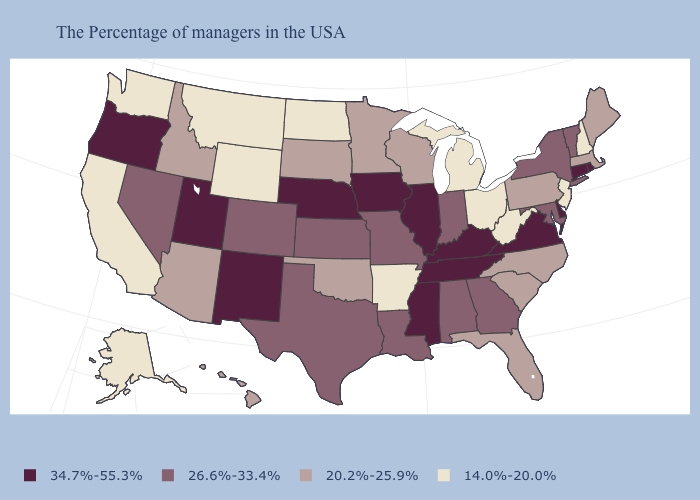Name the states that have a value in the range 20.2%-25.9%?
Concise answer only. Maine, Massachusetts, Pennsylvania, North Carolina, South Carolina, Florida, Wisconsin, Minnesota, Oklahoma, South Dakota, Arizona, Idaho, Hawaii. What is the value of Ohio?
Answer briefly. 14.0%-20.0%. Does Illinois have the highest value in the MidWest?
Give a very brief answer. Yes. What is the value of Washington?
Concise answer only. 14.0%-20.0%. What is the value of Nevada?
Keep it brief. 26.6%-33.4%. What is the value of Idaho?
Short answer required. 20.2%-25.9%. Name the states that have a value in the range 20.2%-25.9%?
Quick response, please. Maine, Massachusetts, Pennsylvania, North Carolina, South Carolina, Florida, Wisconsin, Minnesota, Oklahoma, South Dakota, Arizona, Idaho, Hawaii. Name the states that have a value in the range 26.6%-33.4%?
Quick response, please. Vermont, New York, Maryland, Georgia, Indiana, Alabama, Louisiana, Missouri, Kansas, Texas, Colorado, Nevada. Name the states that have a value in the range 34.7%-55.3%?
Write a very short answer. Rhode Island, Connecticut, Delaware, Virginia, Kentucky, Tennessee, Illinois, Mississippi, Iowa, Nebraska, New Mexico, Utah, Oregon. What is the highest value in the MidWest ?
Be succinct. 34.7%-55.3%. How many symbols are there in the legend?
Write a very short answer. 4. Name the states that have a value in the range 14.0%-20.0%?
Concise answer only. New Hampshire, New Jersey, West Virginia, Ohio, Michigan, Arkansas, North Dakota, Wyoming, Montana, California, Washington, Alaska. Does the first symbol in the legend represent the smallest category?
Give a very brief answer. No. Name the states that have a value in the range 20.2%-25.9%?
Be succinct. Maine, Massachusetts, Pennsylvania, North Carolina, South Carolina, Florida, Wisconsin, Minnesota, Oklahoma, South Dakota, Arizona, Idaho, Hawaii. 